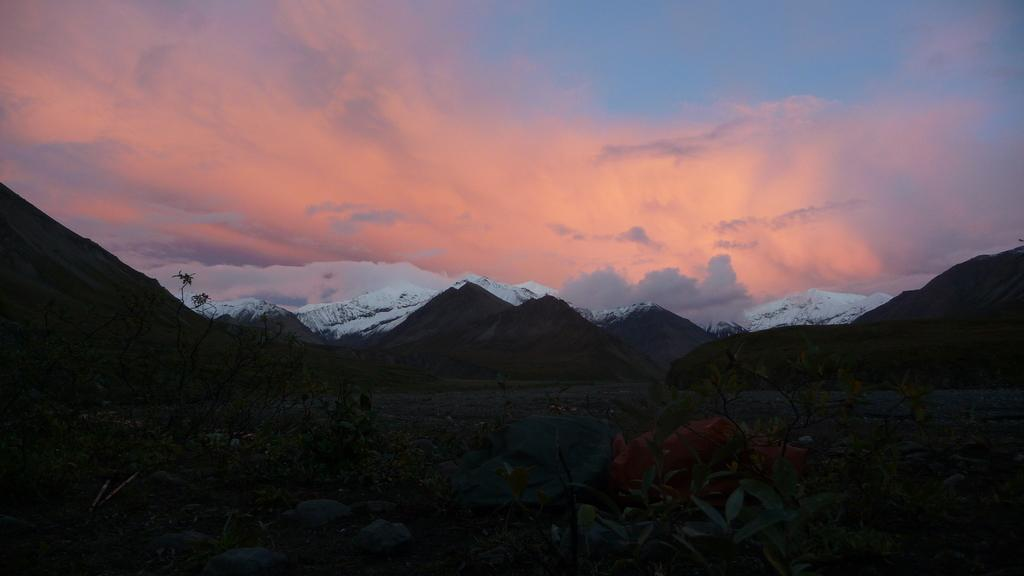What type of natural elements can be seen in the image? There are plants and snowy mountains in the image. What is visible in the background of the image? The sky is visible in the background of the image. What type of current can be seen flowing through the plants in the image? There is no current visible in the image; it features plants and snowy mountains with a visible sky. 